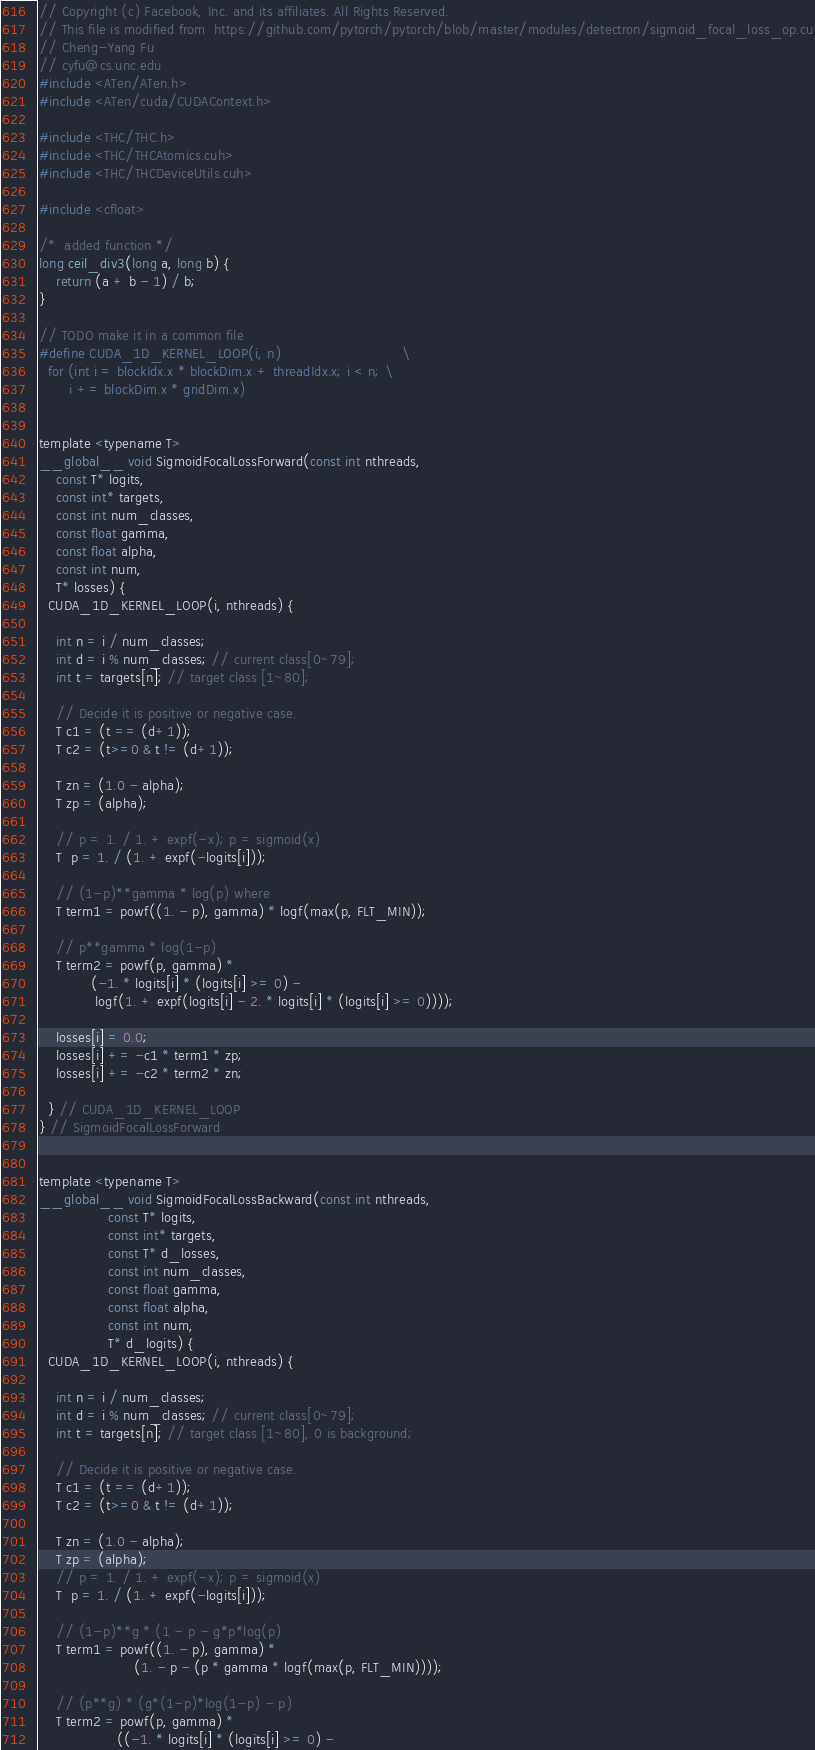Convert code to text. <code><loc_0><loc_0><loc_500><loc_500><_Cuda_>// Copyright (c) Facebook, Inc. and its affiliates. All Rights Reserved.
// This file is modified from  https://github.com/pytorch/pytorch/blob/master/modules/detectron/sigmoid_focal_loss_op.cu
// Cheng-Yang Fu
// cyfu@cs.unc.edu
#include <ATen/ATen.h>
#include <ATen/cuda/CUDAContext.h>

#include <THC/THC.h>
#include <THC/THCAtomics.cuh>
#include <THC/THCDeviceUtils.cuh>

#include <cfloat>

/*  added function */
long ceil_div3(long a, long b) { 
	return (a + b - 1) / b; 
}

// TODO make it in a common file
#define CUDA_1D_KERNEL_LOOP(i, n)                            \
  for (int i = blockIdx.x * blockDim.x + threadIdx.x; i < n; \
       i += blockDim.x * gridDim.x)


template <typename T>
__global__ void SigmoidFocalLossForward(const int nthreads, 
    const T* logits,
    const int* targets,
    const int num_classes,
    const float gamma, 
    const float alpha,
    const int num, 
    T* losses) {
  CUDA_1D_KERNEL_LOOP(i, nthreads) {

    int n = i / num_classes;
    int d = i % num_classes; // current class[0~79]; 
    int t = targets[n]; // target class [1~80];

    // Decide it is positive or negative case. 
    T c1 = (t == (d+1)); 
    T c2 = (t>=0 & t != (d+1));

    T zn = (1.0 - alpha);
    T zp = (alpha);

    // p = 1. / 1. + expf(-x); p = sigmoid(x)
    T  p = 1. / (1. + expf(-logits[i]));

    // (1-p)**gamma * log(p) where
    T term1 = powf((1. - p), gamma) * logf(max(p, FLT_MIN));

    // p**gamma * log(1-p)
    T term2 = powf(p, gamma) *
            (-1. * logits[i] * (logits[i] >= 0) -   
             logf(1. + expf(logits[i] - 2. * logits[i] * (logits[i] >= 0))));

    losses[i] = 0.0;
    losses[i] += -c1 * term1 * zp;
    losses[i] += -c2 * term2 * zn;

  } // CUDA_1D_KERNEL_LOOP
} // SigmoidFocalLossForward


template <typename T>
__global__ void SigmoidFocalLossBackward(const int nthreads,
                const T* logits,
                const int* targets,
                const T* d_losses,
                const int num_classes,
                const float gamma,
                const float alpha,
                const int num,
                T* d_logits) {
  CUDA_1D_KERNEL_LOOP(i, nthreads) {

    int n = i / num_classes;
    int d = i % num_classes; // current class[0~79]; 
    int t = targets[n]; // target class [1~80], 0 is background;

    // Decide it is positive or negative case. 
    T c1 = (t == (d+1));
    T c2 = (t>=0 & t != (d+1));

    T zn = (1.0 - alpha);
    T zp = (alpha);
    // p = 1. / 1. + expf(-x); p = sigmoid(x)
    T  p = 1. / (1. + expf(-logits[i]));

    // (1-p)**g * (1 - p - g*p*log(p)
    T term1 = powf((1. - p), gamma) *
                      (1. - p - (p * gamma * logf(max(p, FLT_MIN))));

    // (p**g) * (g*(1-p)*log(1-p) - p)
    T term2 = powf(p, gamma) *
                  ((-1. * logits[i] * (logits[i] >= 0) -</code> 